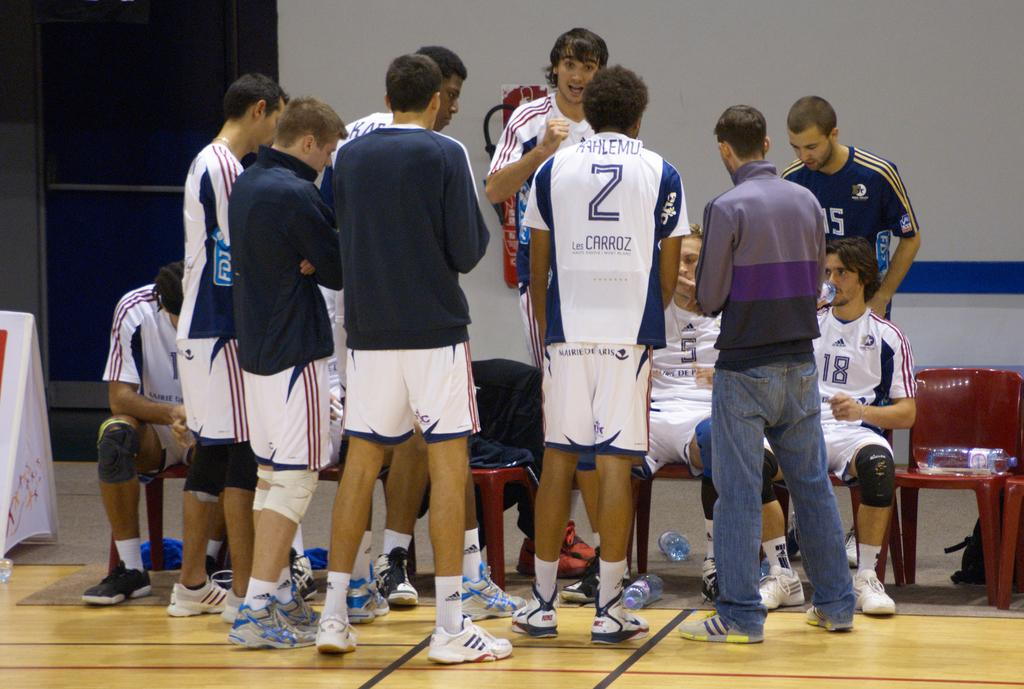Provide a one-sentence caption for the provided image. some young men sports players hanging out together, one player has a 2 on his shirt with KAHLEMU Les Carroz. 